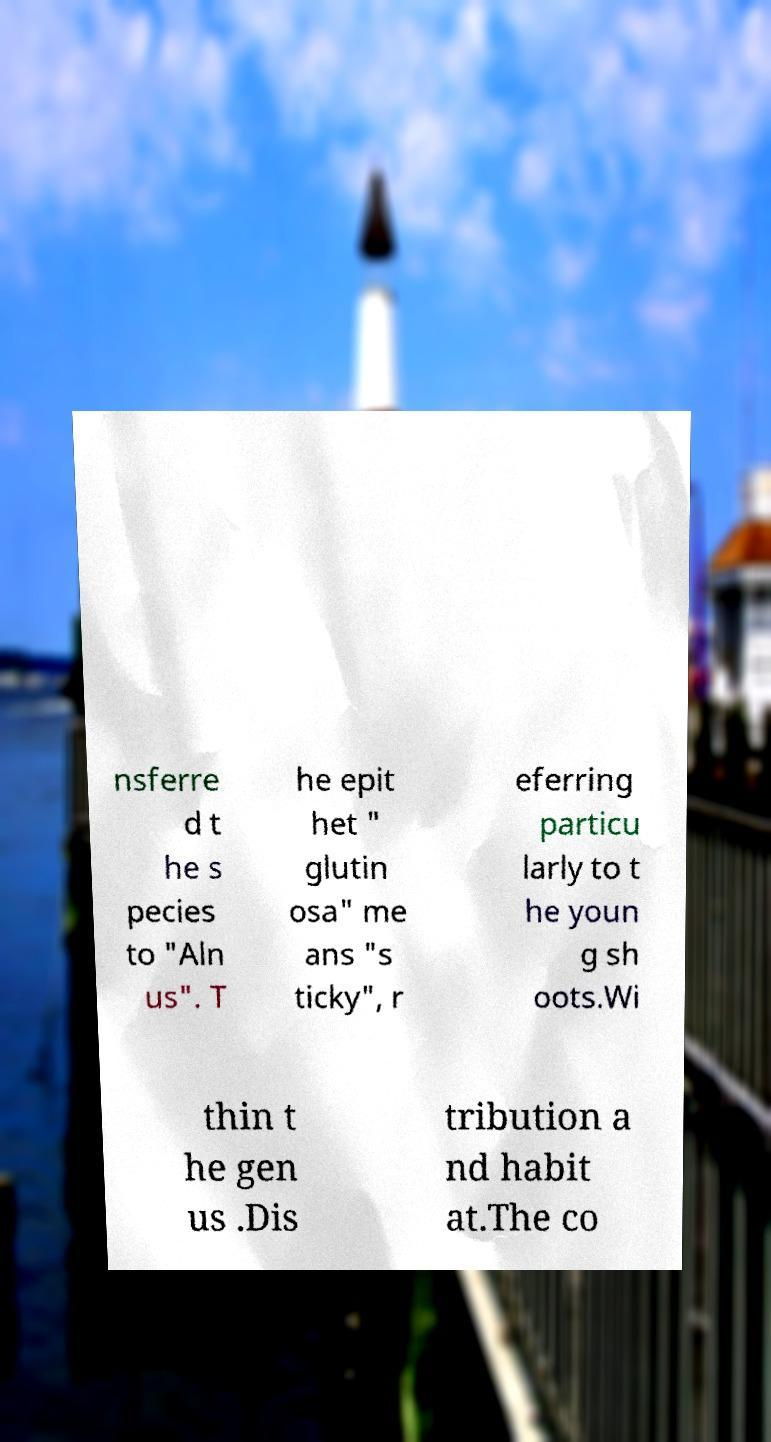What messages or text are displayed in this image? I need them in a readable, typed format. nsferre d t he s pecies to "Aln us". T he epit het " glutin osa" me ans "s ticky", r eferring particu larly to t he youn g sh oots.Wi thin t he gen us .Dis tribution a nd habit at.The co 